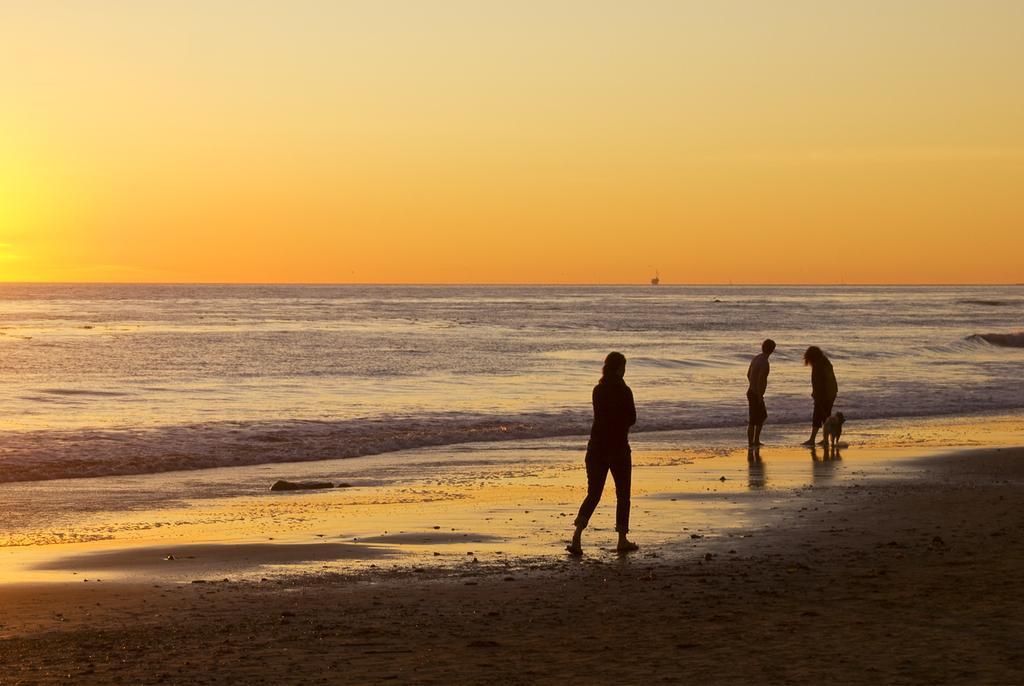How would you summarize this image in a sentence or two? In the middle of the image three persons standing and there is an animal. Behind them there is water. At the top of the image there is sky. 